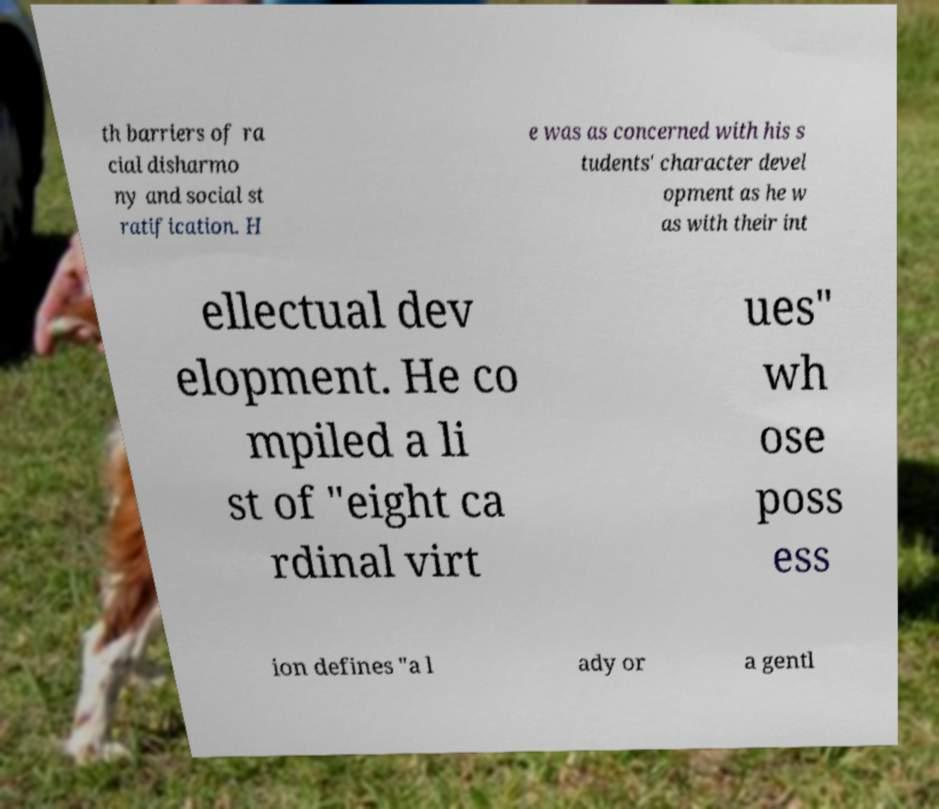Could you assist in decoding the text presented in this image and type it out clearly? th barriers of ra cial disharmo ny and social st ratification. H e was as concerned with his s tudents' character devel opment as he w as with their int ellectual dev elopment. He co mpiled a li st of "eight ca rdinal virt ues" wh ose poss ess ion defines "a l ady or a gentl 